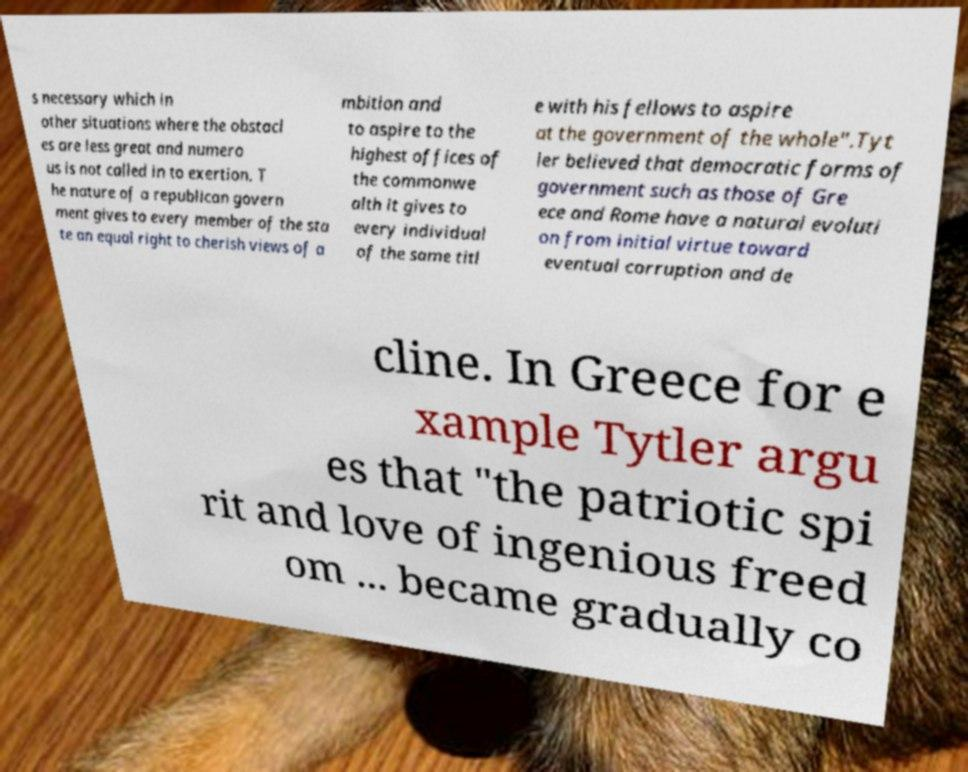What messages or text are displayed in this image? I need them in a readable, typed format. s necessary which in other situations where the obstacl es are less great and numero us is not called in to exertion. T he nature of a republican govern ment gives to every member of the sta te an equal right to cherish views of a mbition and to aspire to the highest offices of the commonwe alth it gives to every individual of the same titl e with his fellows to aspire at the government of the whole".Tyt ler believed that democratic forms of government such as those of Gre ece and Rome have a natural evoluti on from initial virtue toward eventual corruption and de cline. In Greece for e xample Tytler argu es that "the patriotic spi rit and love of ingenious freed om ... became gradually co 